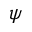<formula> <loc_0><loc_0><loc_500><loc_500>\psi</formula> 